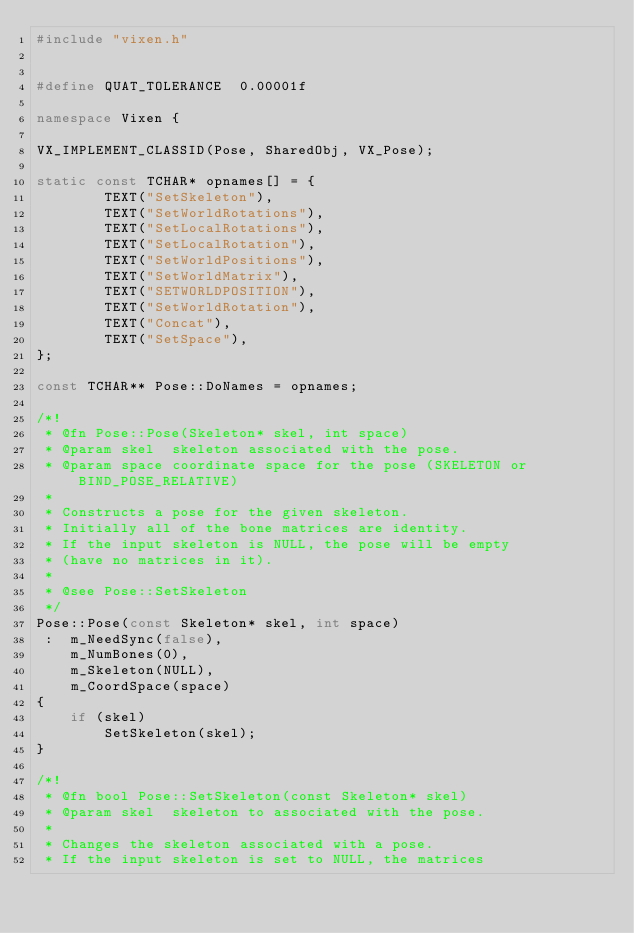<code> <loc_0><loc_0><loc_500><loc_500><_C++_>#include "vixen.h"


#define QUAT_TOLERANCE	0.00001f

namespace Vixen {

VX_IMPLEMENT_CLASSID(Pose, SharedObj, VX_Pose);

static const TCHAR* opnames[] = {
		TEXT("SetSkeleton"),
		TEXT("SetWorldRotations"),
		TEXT("SetLocalRotations"),
		TEXT("SetLocalRotation"),
		TEXT("SetWorldPositions"),
		TEXT("SetWorldMatrix"),
		TEXT("SETWORLDPOSITION"),
		TEXT("SetWorldRotation"),
		TEXT("Concat"),
		TEXT("SetSpace"),
};

const TCHAR** Pose::DoNames = opnames;

/*!
 * @fn Pose::Pose(Skeleton* skel, int space)
 * @param skel	skeleton associated with the pose.
 * @param space	coordinate space for the pose (SKELETON or BIND_POSE_RELATIVE)
 *
 * Constructs a pose for the given skeleton.
 * Initially all of the bone matrices are identity.
 * If the input skeleton is NULL, the pose will be empty
 * (have no matrices in it).
 *
 * @see Pose::SetSkeleton
 */
Pose::Pose(const Skeleton* skel, int space)
 :	m_NeedSync(false),
	m_NumBones(0),
	m_Skeleton(NULL),
	m_CoordSpace(space)
{
	if (skel)
		SetSkeleton(skel);
}

/*!
 * @fn bool Pose::SetSkeleton(const Skeleton* skel)
 * @param skel	skeleton to associated with the pose.
 *
 * Changes the skeleton associated with a pose.
 * If the input skeleton is set to NULL, the matrices</code> 